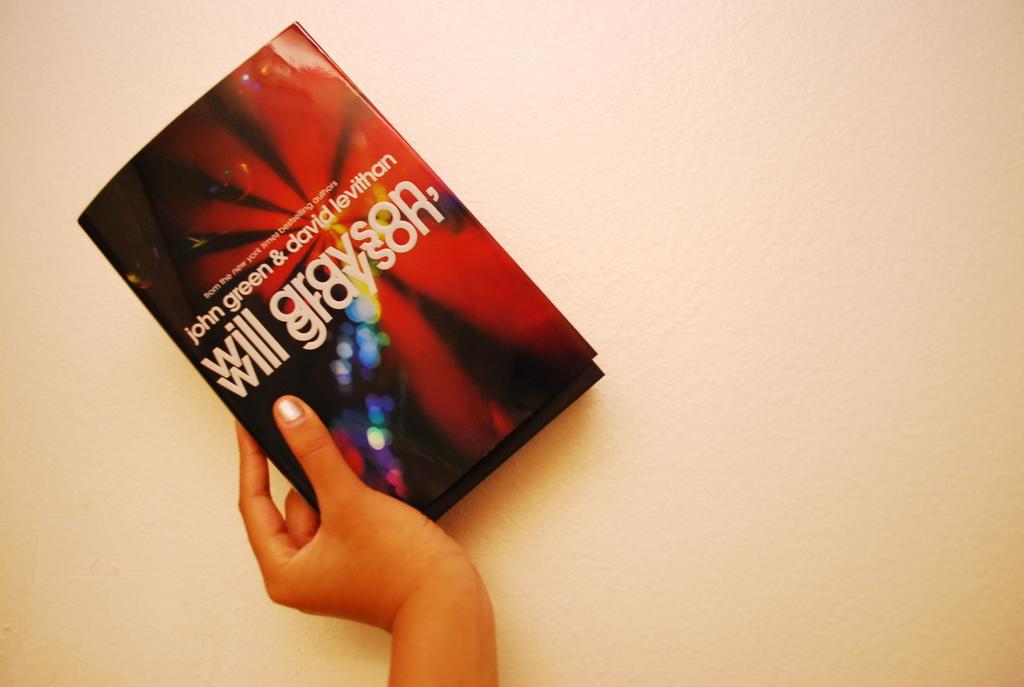What is the title of this book?
Your answer should be compact. Will grayson. 